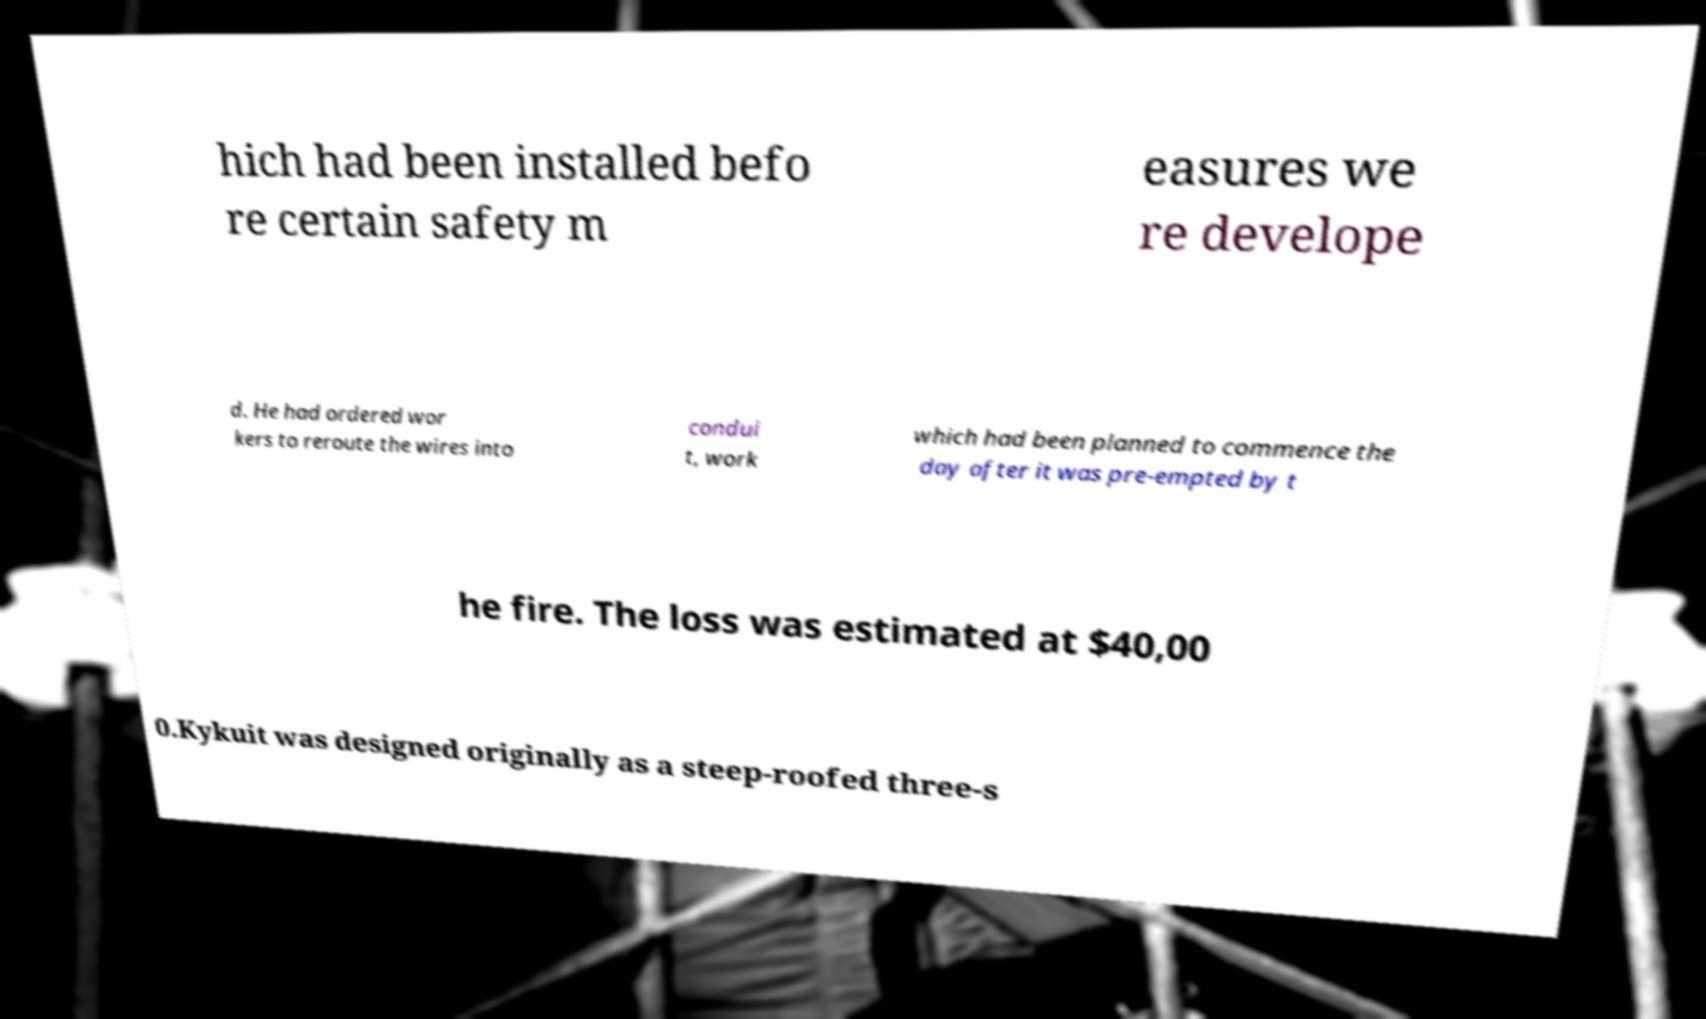Please read and relay the text visible in this image. What does it say? hich had been installed befo re certain safety m easures we re develope d. He had ordered wor kers to reroute the wires into condui t, work which had been planned to commence the day after it was pre-empted by t he fire. The loss was estimated at $40,00 0.Kykuit was designed originally as a steep-roofed three-s 